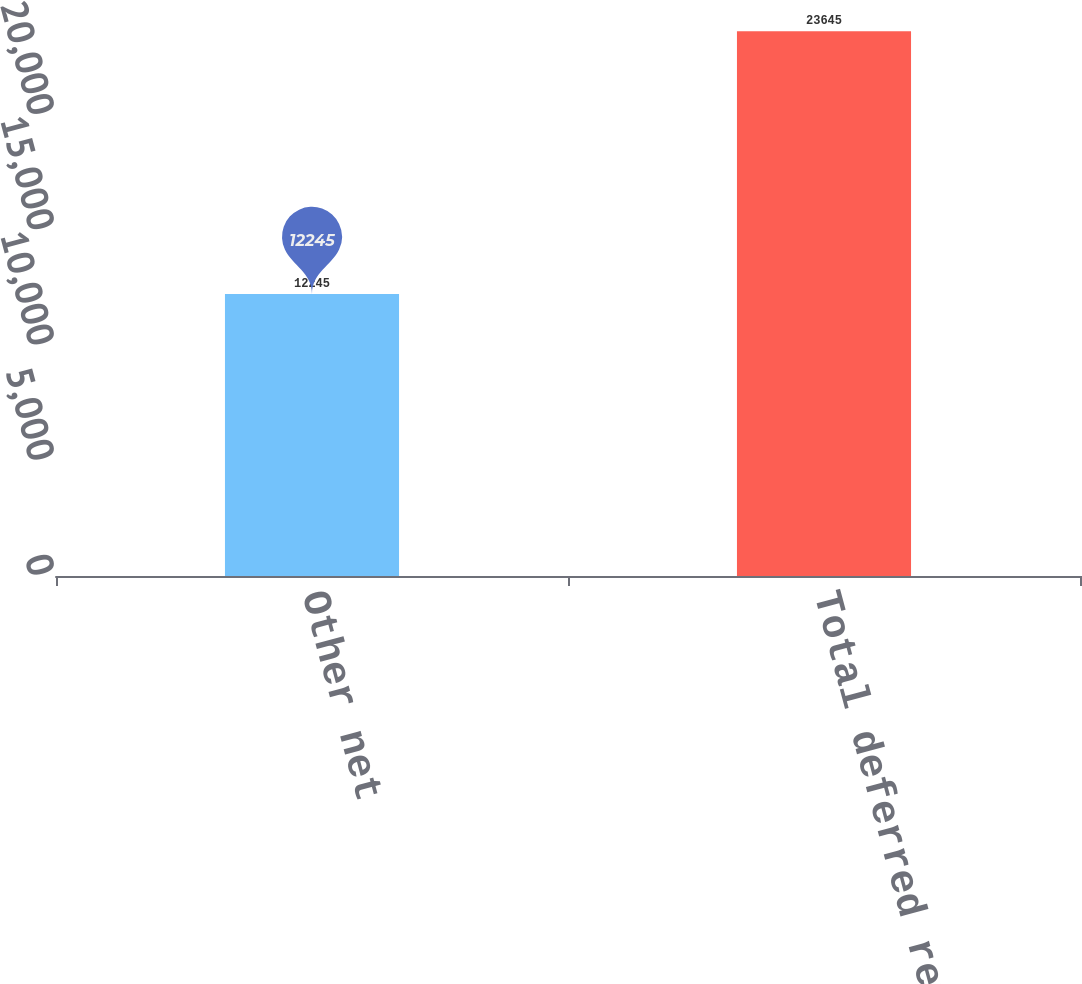<chart> <loc_0><loc_0><loc_500><loc_500><bar_chart><fcel>Other net<fcel>Total deferred revenue<nl><fcel>12245<fcel>23645<nl></chart> 